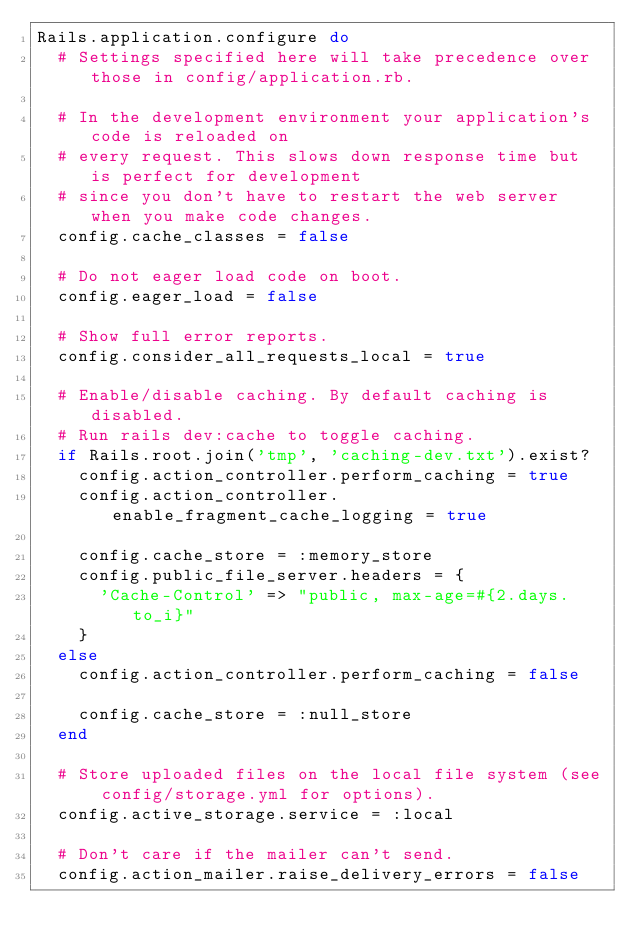Convert code to text. <code><loc_0><loc_0><loc_500><loc_500><_Ruby_>Rails.application.configure do
  # Settings specified here will take precedence over those in config/application.rb.

  # In the development environment your application's code is reloaded on
  # every request. This slows down response time but is perfect for development
  # since you don't have to restart the web server when you make code changes.
  config.cache_classes = false

  # Do not eager load code on boot.
  config.eager_load = false

  # Show full error reports.
  config.consider_all_requests_local = true

  # Enable/disable caching. By default caching is disabled.
  # Run rails dev:cache to toggle caching.
  if Rails.root.join('tmp', 'caching-dev.txt').exist?
    config.action_controller.perform_caching = true
    config.action_controller.enable_fragment_cache_logging = true

    config.cache_store = :memory_store
    config.public_file_server.headers = {
      'Cache-Control' => "public, max-age=#{2.days.to_i}"
    }
  else
    config.action_controller.perform_caching = false

    config.cache_store = :null_store
  end

  # Store uploaded files on the local file system (see config/storage.yml for options).
  config.active_storage.service = :local

  # Don't care if the mailer can't send.
  config.action_mailer.raise_delivery_errors = false
</code> 